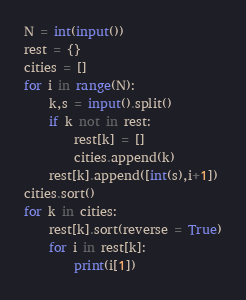<code> <loc_0><loc_0><loc_500><loc_500><_Python_>N = int(input())
rest = {}
cities = []
for i in range(N):
    k,s = input().split()
    if k not in rest:
        rest[k] = []
        cities.append(k)
    rest[k].append([int(s),i+1])
cities.sort()
for k in cities:
    rest[k].sort(reverse = True)
    for i in rest[k]:
        print(i[1])</code> 